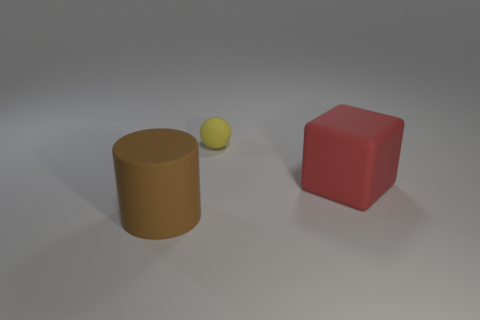Add 2 yellow matte spheres. How many objects exist? 5 Subtract all cylinders. How many objects are left? 2 Subtract all gray balls. Subtract all cyan blocks. How many balls are left? 1 Subtract all blocks. Subtract all cyan metal balls. How many objects are left? 2 Add 3 big red matte blocks. How many big red matte blocks are left? 4 Add 3 gray cubes. How many gray cubes exist? 3 Subtract 0 cyan cubes. How many objects are left? 3 